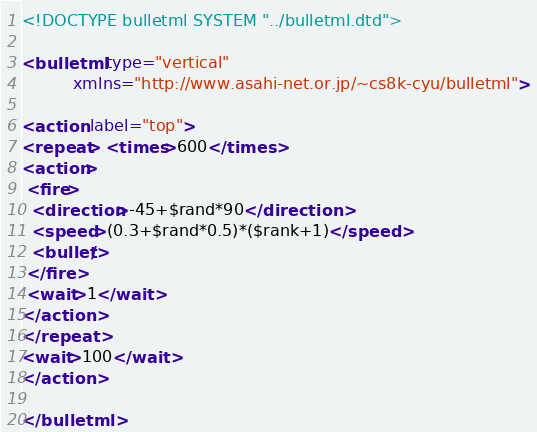Convert code to text. <code><loc_0><loc_0><loc_500><loc_500><_XML_><!DOCTYPE bulletml SYSTEM "../bulletml.dtd">

<bulletml type="vertical"
          xmlns="http://www.asahi-net.or.jp/~cs8k-cyu/bulletml">

<action label="top">
<repeat> <times>600</times>
<action>
 <fire>
  <direction>-45+$rand*90</direction>
  <speed>(0.3+$rand*0.5)*($rank+1)</speed>
  <bullet/>
 </fire>
 <wait>1</wait>
</action>
</repeat>
<wait>100</wait>
</action>

</bulletml>
</code> 